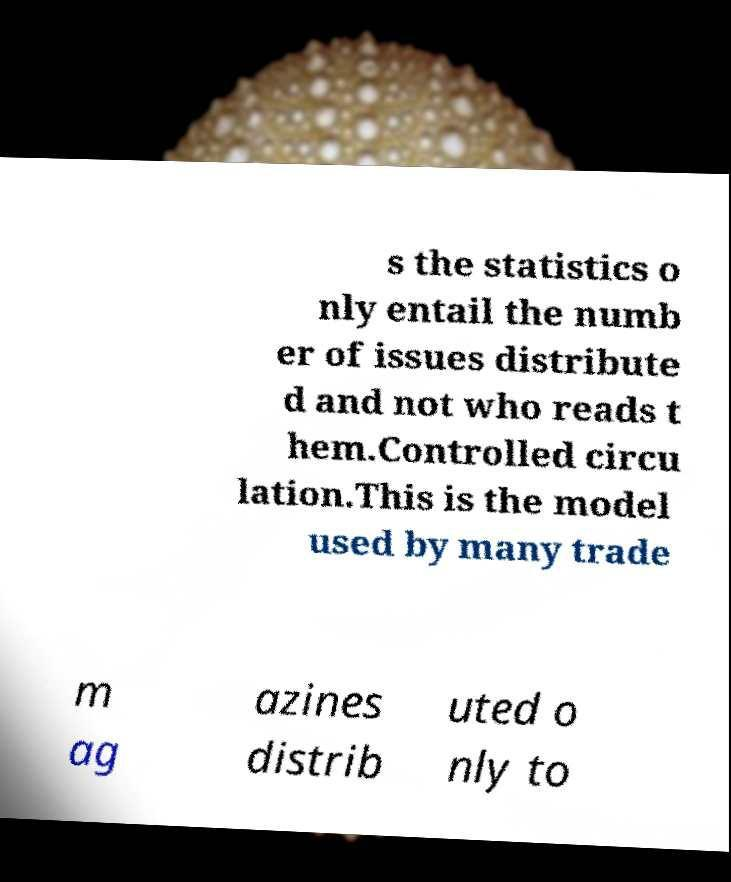For documentation purposes, I need the text within this image transcribed. Could you provide that? s the statistics o nly entail the numb er of issues distribute d and not who reads t hem.Controlled circu lation.This is the model used by many trade m ag azines distrib uted o nly to 